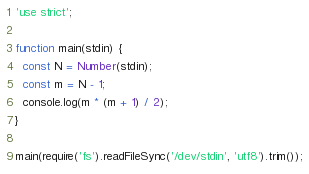Convert code to text. <code><loc_0><loc_0><loc_500><loc_500><_JavaScript_>'use strict';

function main(stdin) {
  const N = Number(stdin);
  const m = N - 1;
  console.log(m * (m + 1) / 2);
}

main(require('fs').readFileSync('/dev/stdin', 'utf8').trim());</code> 